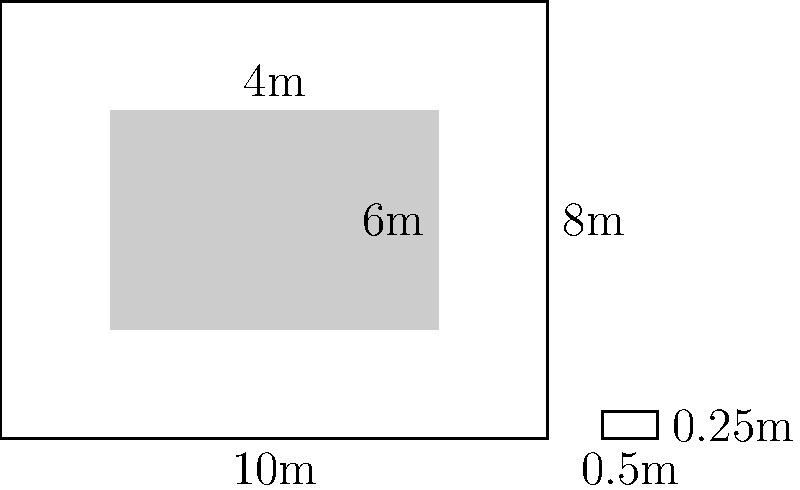A historic church's facade needs restoration. The damaged area is rectangular, measuring 6m wide and 4m high, centered on the facade. If the stones used for restoration are 0.5m x 0.25m, how many stones are needed to cover the damaged area? To determine the number of stones needed, we'll follow these steps:

1. Calculate the area of the damaged section:
   Area = width × height
   $$ A = 6\text{ m} \times 4\text{ m} = 24\text{ m}^2 $$

2. Calculate the area of a single stone:
   Stone area = length × width
   $$ A_s = 0.5\text{ m} \times 0.25\text{ m} = 0.125\text{ m}^2 $$

3. Calculate the number of stones needed:
   Number of stones = Damaged area ÷ Stone area
   $$ N = \frac{24\text{ m}^2}{0.125\text{ m}^2} = 192 $$

4. Round up to the nearest whole number, as we can't use partial stones:
   $$ N = \lceil 192 \rceil = 192 $$

Therefore, 192 stones are needed to cover the damaged area of the church facade.
Answer: 192 stones 